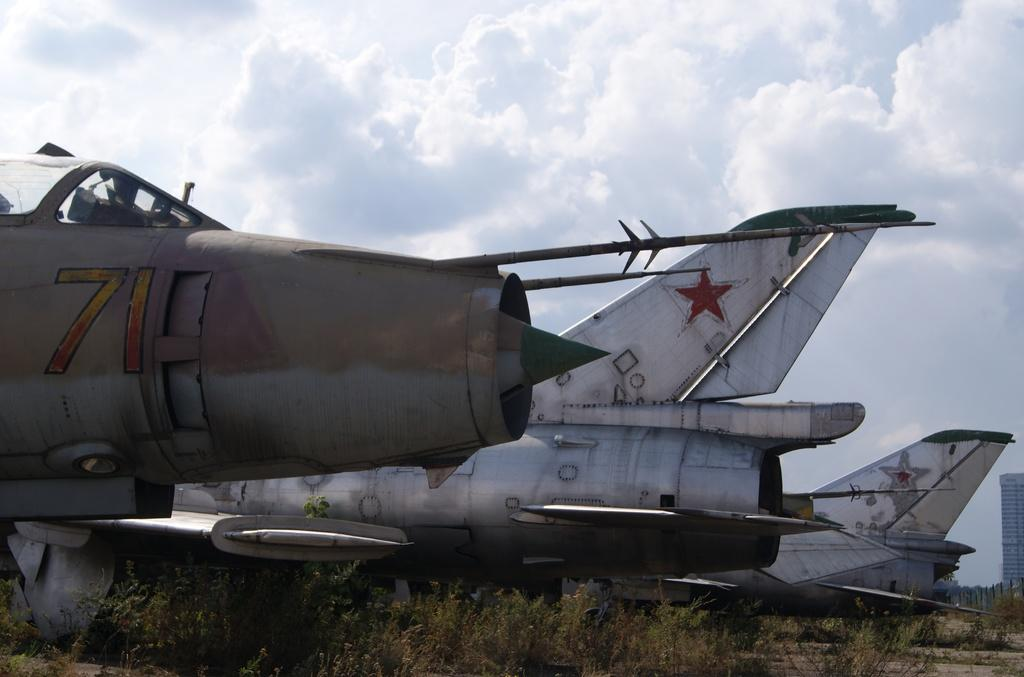<image>
Provide a brief description of the given image. Three planes are on a field and one of the plane has number 71 on it. 